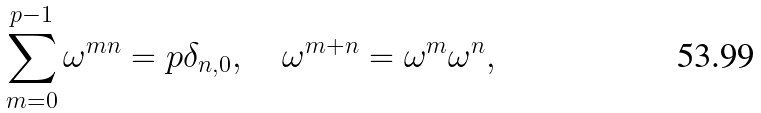Convert formula to latex. <formula><loc_0><loc_0><loc_500><loc_500>\sum _ { m = 0 } ^ { p - 1 } \omega ^ { m n } = p \delta _ { n , 0 } , \quad \omega ^ { m + n } = \omega ^ { m } \omega ^ { n } ,</formula> 